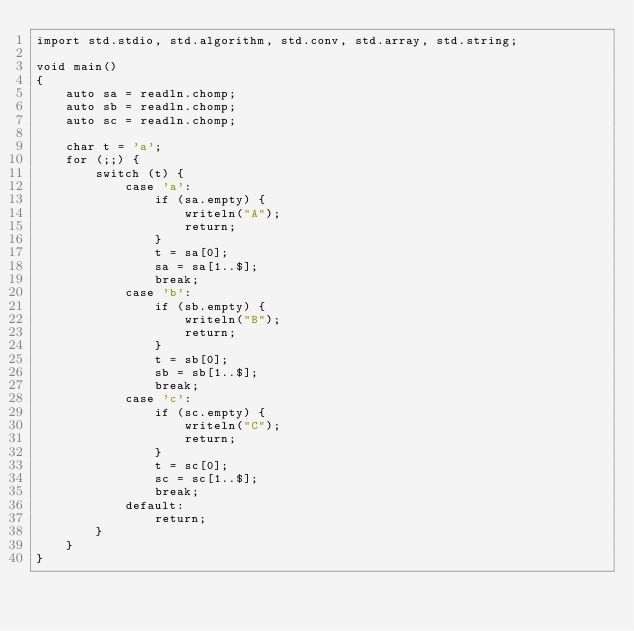Convert code to text. <code><loc_0><loc_0><loc_500><loc_500><_D_>import std.stdio, std.algorithm, std.conv, std.array, std.string;

void main()
{
    auto sa = readln.chomp;
    auto sb = readln.chomp;
    auto sc = readln.chomp;

    char t = 'a';
    for (;;) {
        switch (t) {
            case 'a':
                if (sa.empty) {
                    writeln("A");
                    return;
                }
                t = sa[0];
                sa = sa[1..$];
                break;
            case 'b':
                if (sb.empty) {
                    writeln("B");
                    return;
                }
                t = sb[0];
                sb = sb[1..$];
                break;
            case 'c':
                if (sc.empty) {
                    writeln("C");
                    return;
                }
                t = sc[0];
                sc = sc[1..$];
                break;
            default:
                return;
        }
    }
}</code> 